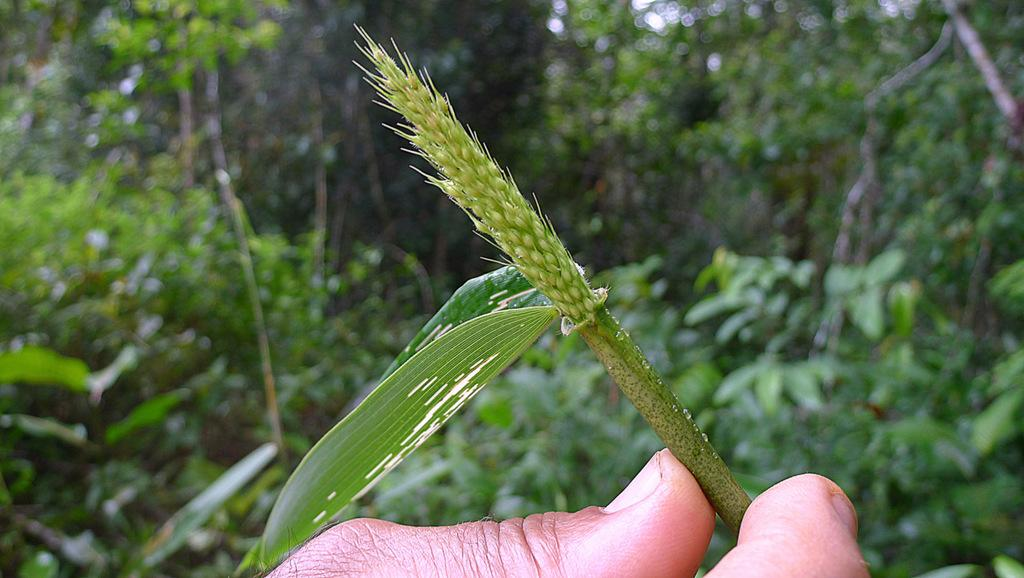What is being held by the fingers in the image? The fingers are holding a leaf in the middle bottom of the image. What can be seen in the background of the image? There are trees and plants in the background of the image. What type of grass is being approved by the person in the image? There is no indication of grass or approval in the image; it only shows fingers holding a leaf and trees and plants in the background. 